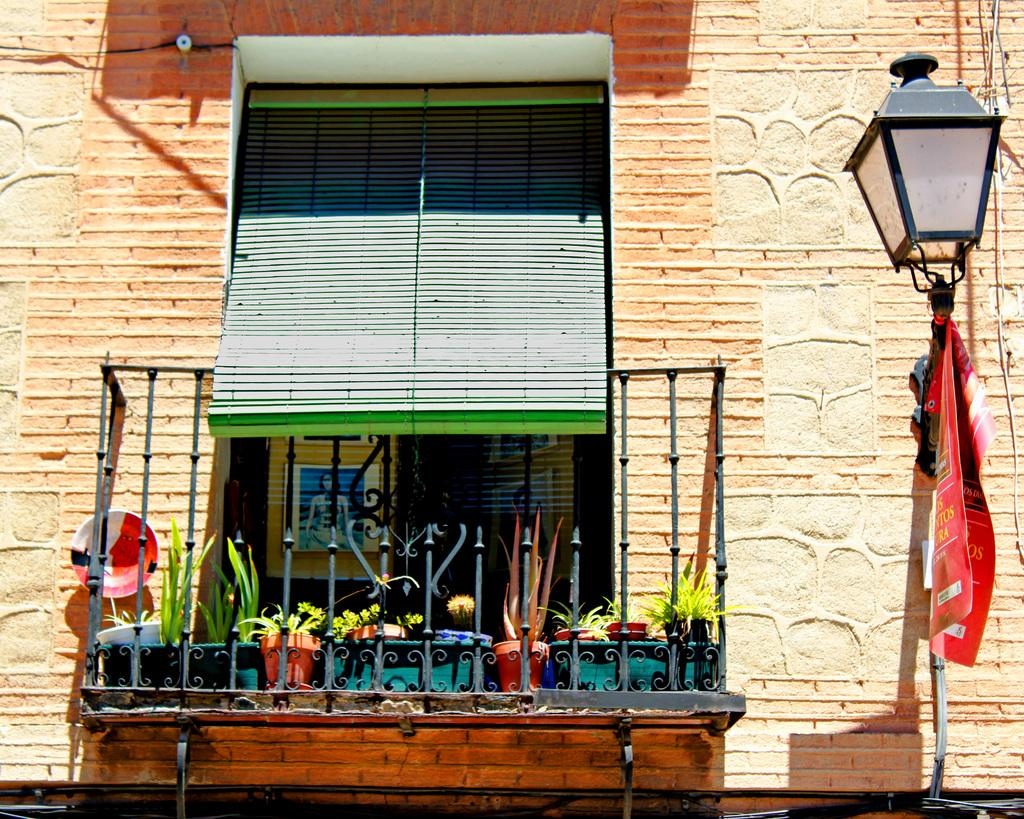What object can be found towards the right side of the image? There is a lamp and a banner towards the right side of the image. What can be seen in the middle of the image? There are flower pots, plants, a corridor, a window blind, and a window in the middle of the image. What type of structure is visible in the image? There is a building's wall visible in the image. What type of toothbrush is being used to clean the window in the image? There is no toothbrush present in the image, and the window is not being cleaned. 